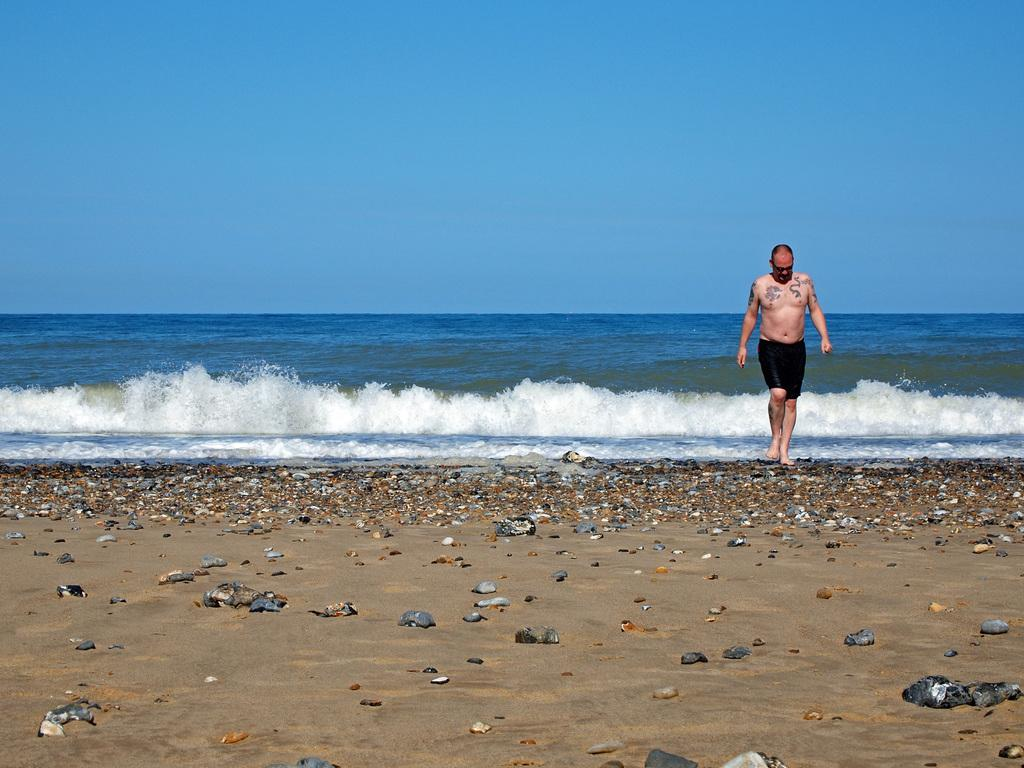Who is present in the image? There is a man in the image. What is the man wearing? The man is wearing shorts. What is the man doing in the image? The man is walking. What type of terrain can be seen in the image? There are stones, sand, and water in the image. What part of the natural environment is visible in the image? The sky is visible in the image. What type of treatment is the man receiving for his sunburn in the image? There is no indication of a sunburn or any treatment in the image. 